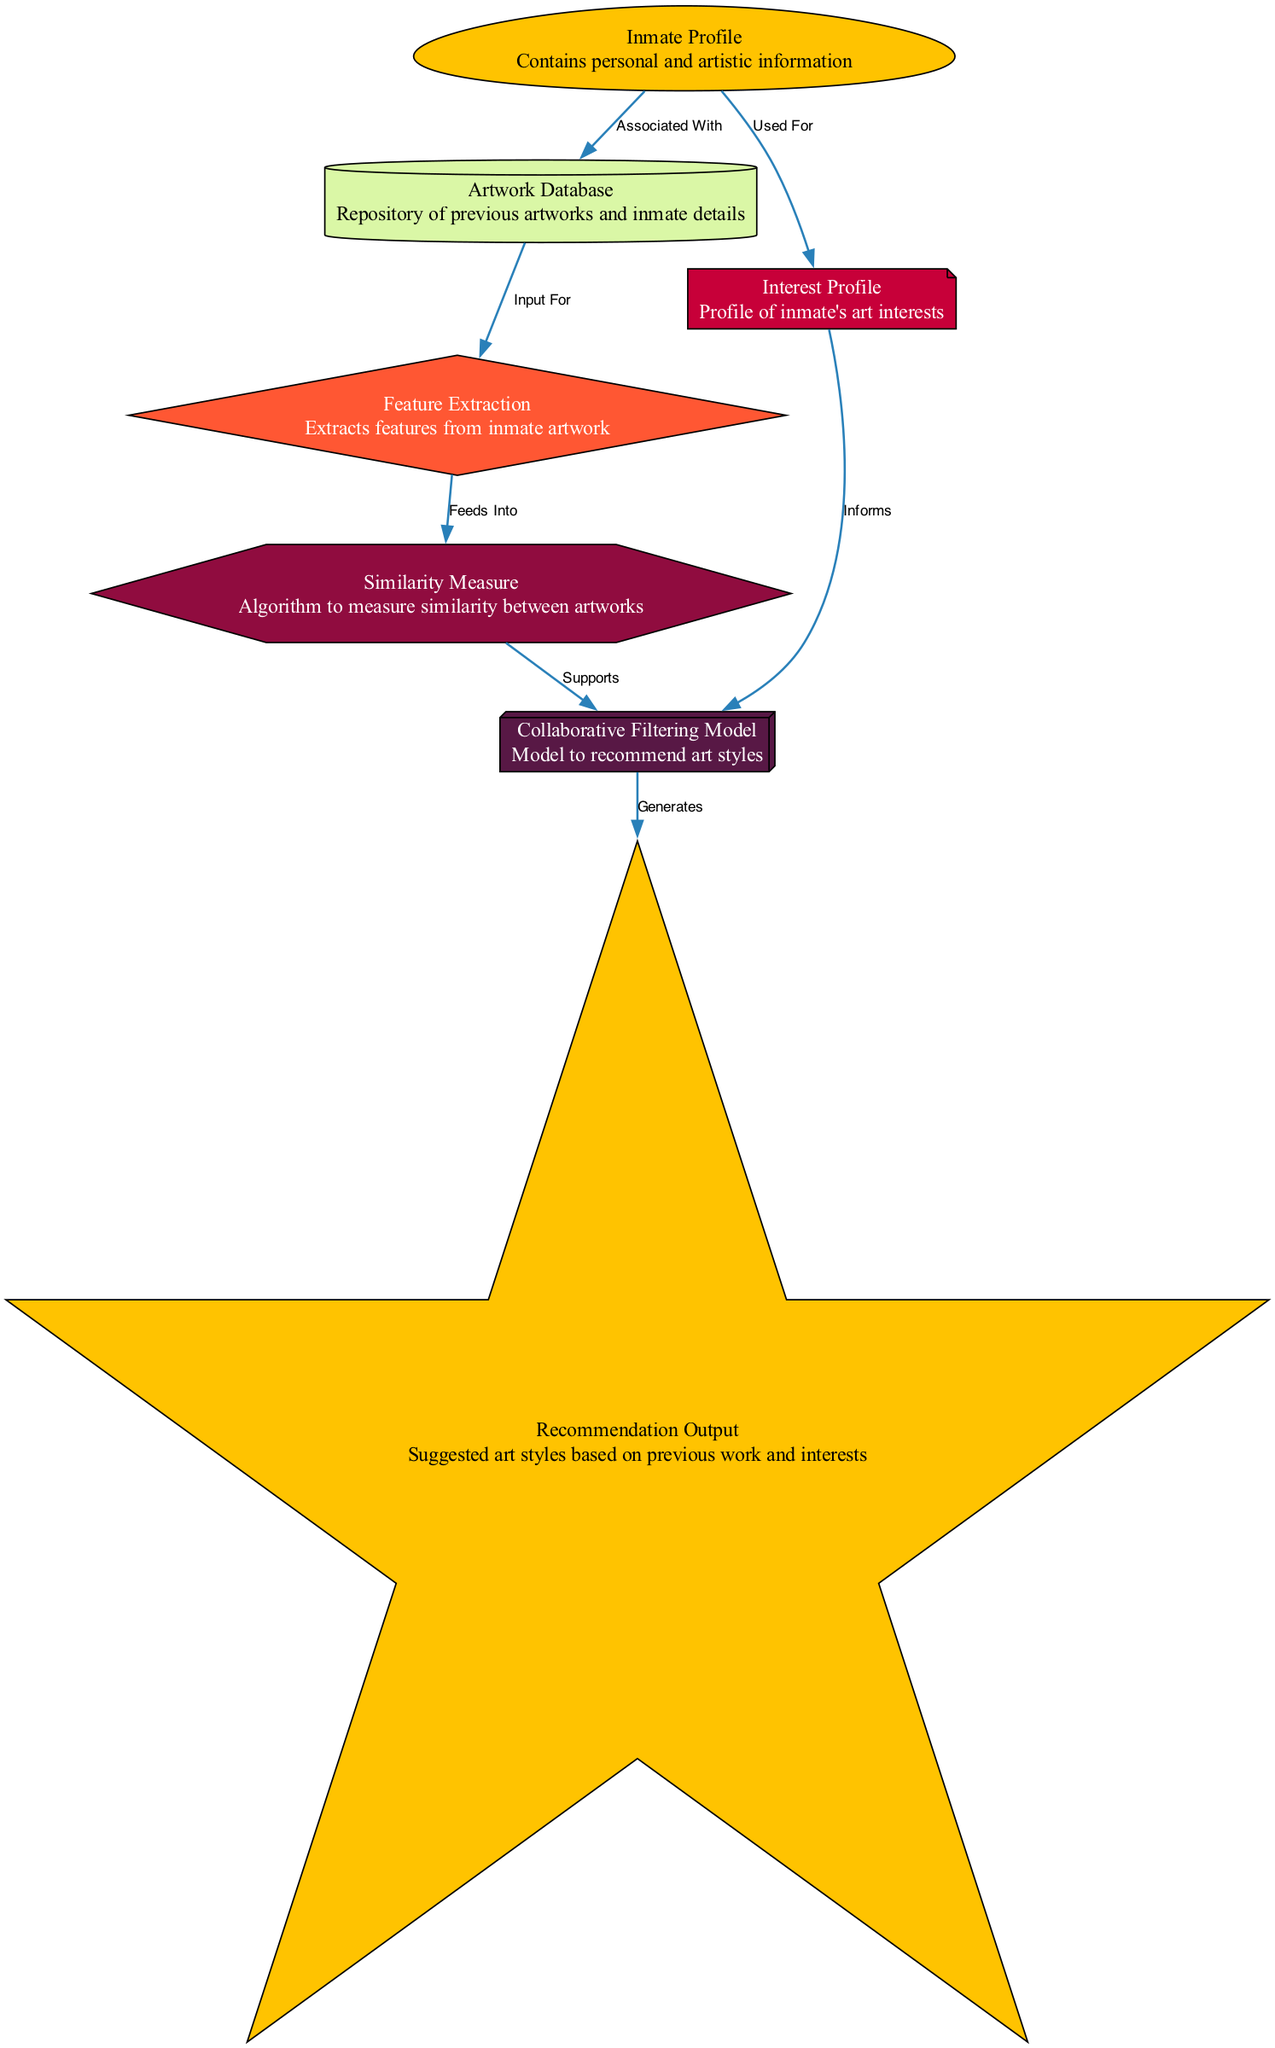What is the role of the "Inmate Profile" node? The "Inmate Profile" node contains personal and artistic information about the inmates, serving as the foundational data for the system.
Answer: Contains personal and artistic information How many nodes exist in the diagram? By counting the nodes listed in the data, there are seven distinct nodes represented in the diagram.
Answer: 7 What type of relationship is indicated between "artwork_database" and "feature_extraction"? The diagram shows that the "artwork_database" provides input for the "feature_extraction" node, indicating a direct flow of data from one to the other.
Answer: Input For What does the "collaborative_filtering_model" generate? The "collaborative_filtering_model" produces the "recommendation_output," which consists of suggested art styles based on the input it has received.
Answer: Suggests art styles Which node informs the "collaborative_filtering_model"? The "interest_profile" node informs the "collaborative_filtering_model" by providing insights into the inmate's art preferences, which is crucial for personalized recommendations.
Answer: Interest Profile What type of node is the "similarity_measure"? The "similarity_measure" node is a hexagon-shaped node that represents the algorithm used to measure the similarity between artworks within the system.
Answer: Hexagon Which edge indicates a supportive relationship? The edge from "similarity_measure" to "collaborative_filtering_model" indicates a supportive relationship, showing that similarity measures enhance the recommendation process.
Answer: Supports How many edges are present in the diagram? By counting the connections (edges) between nodes, there are six edges present in the diagram that define the relationships and data flow.
Answer: 6 Which node feeds into the "similarity_measure"? The "feature_extraction" node feeds into the "similarity_measure," providing extracted features from inmate artwork to enable similarity assessments.
Answer: Feeds Into How is the output of the system generated? The output is generated by the "collaborative_filtering_model," which combines data from both the "interest_profile" and "similarity_measure" to produce the final recommendations.
Answer: Generates 